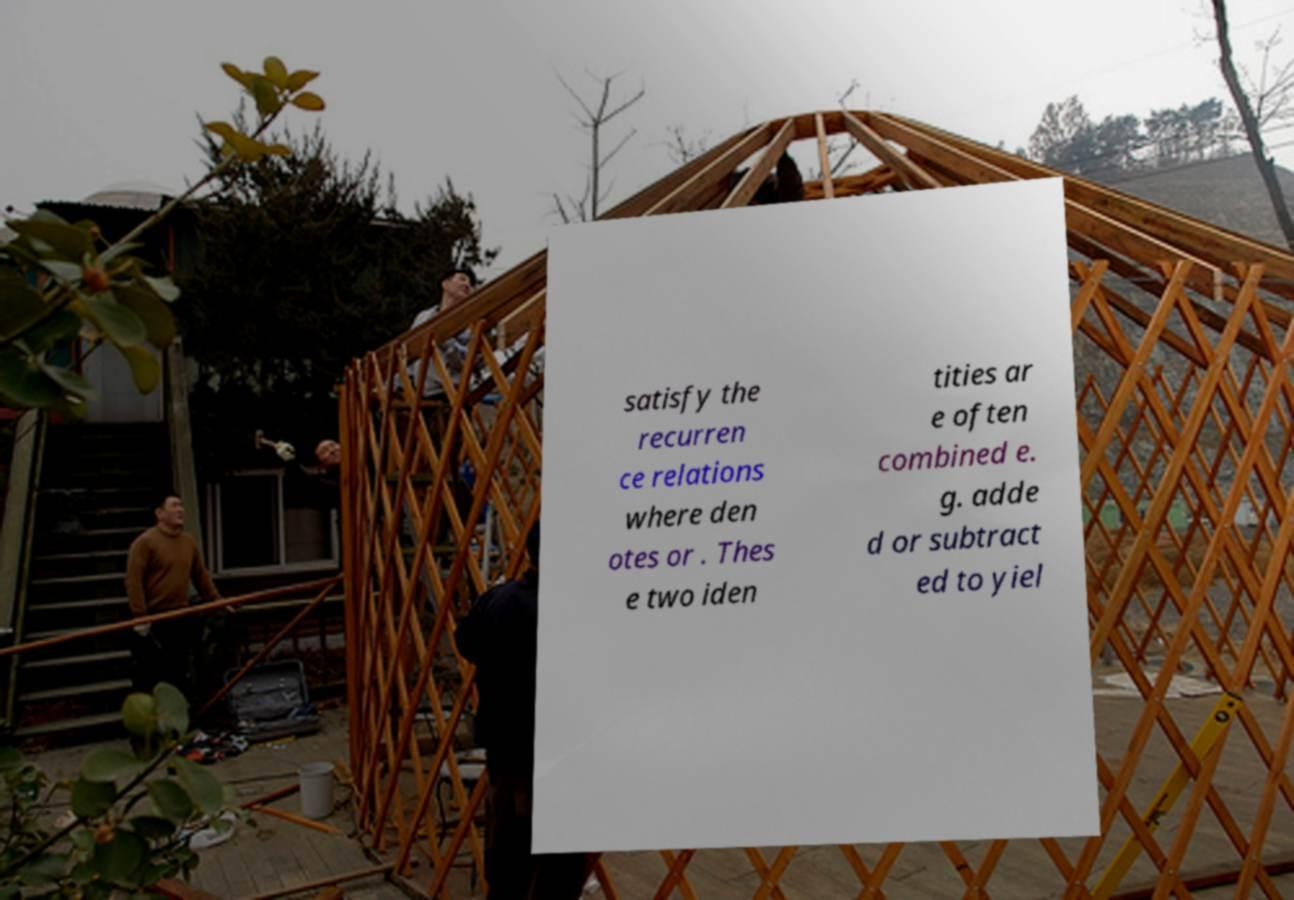Please identify and transcribe the text found in this image. satisfy the recurren ce relations where den otes or . Thes e two iden tities ar e often combined e. g. adde d or subtract ed to yiel 